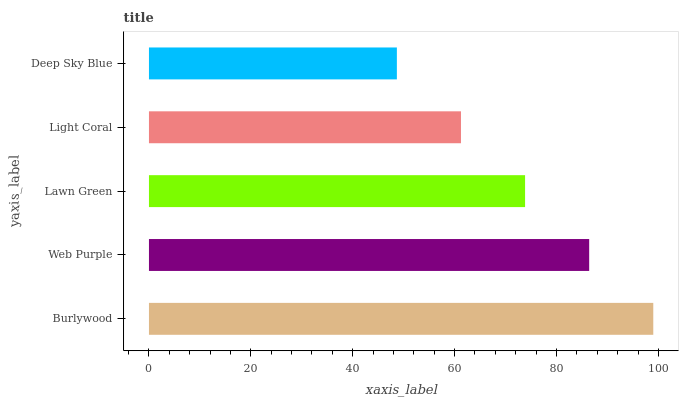Is Deep Sky Blue the minimum?
Answer yes or no. Yes. Is Burlywood the maximum?
Answer yes or no. Yes. Is Web Purple the minimum?
Answer yes or no. No. Is Web Purple the maximum?
Answer yes or no. No. Is Burlywood greater than Web Purple?
Answer yes or no. Yes. Is Web Purple less than Burlywood?
Answer yes or no. Yes. Is Web Purple greater than Burlywood?
Answer yes or no. No. Is Burlywood less than Web Purple?
Answer yes or no. No. Is Lawn Green the high median?
Answer yes or no. Yes. Is Lawn Green the low median?
Answer yes or no. Yes. Is Burlywood the high median?
Answer yes or no. No. Is Burlywood the low median?
Answer yes or no. No. 